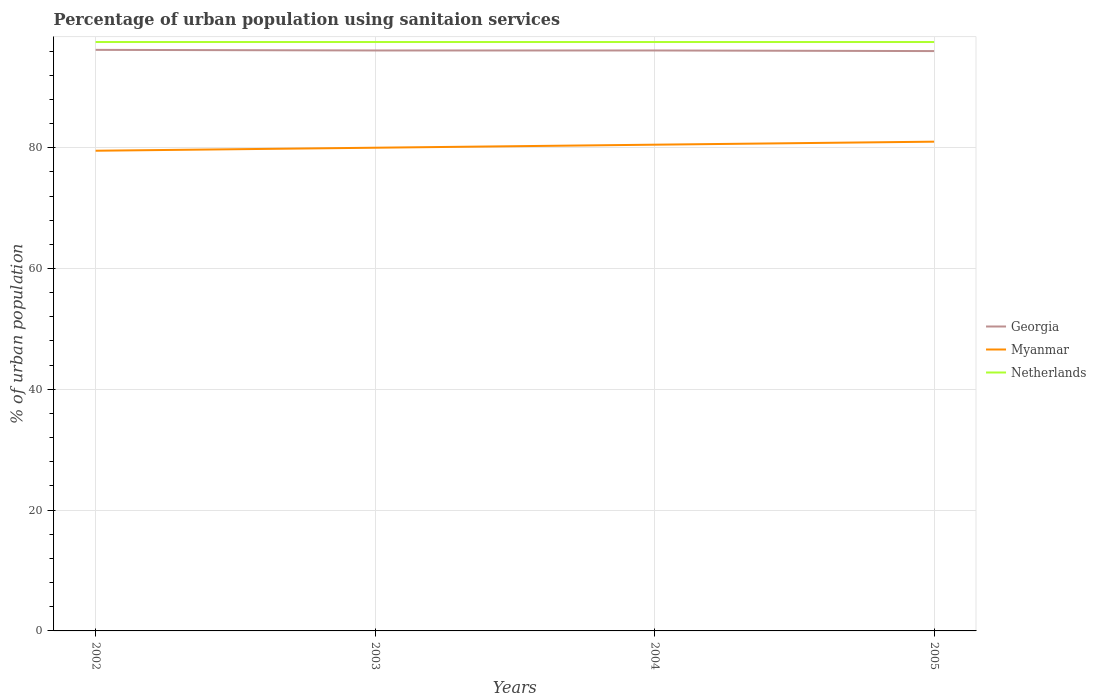Does the line corresponding to Netherlands intersect with the line corresponding to Myanmar?
Provide a succinct answer. No. Is the number of lines equal to the number of legend labels?
Your response must be concise. Yes. Across all years, what is the maximum percentage of urban population using sanitaion services in Myanmar?
Your answer should be very brief. 79.5. What is the difference between the highest and the second highest percentage of urban population using sanitaion services in Georgia?
Your answer should be very brief. 0.2. What is the difference between the highest and the lowest percentage of urban population using sanitaion services in Netherlands?
Keep it short and to the point. 0. What is the difference between two consecutive major ticks on the Y-axis?
Give a very brief answer. 20. Are the values on the major ticks of Y-axis written in scientific E-notation?
Provide a succinct answer. No. Does the graph contain any zero values?
Your answer should be compact. No. How many legend labels are there?
Make the answer very short. 3. What is the title of the graph?
Offer a terse response. Percentage of urban population using sanitaion services. What is the label or title of the Y-axis?
Ensure brevity in your answer.  % of urban population. What is the % of urban population of Georgia in 2002?
Provide a succinct answer. 96.2. What is the % of urban population in Myanmar in 2002?
Give a very brief answer. 79.5. What is the % of urban population of Netherlands in 2002?
Keep it short and to the point. 97.5. What is the % of urban population in Georgia in 2003?
Make the answer very short. 96.1. What is the % of urban population of Myanmar in 2003?
Offer a very short reply. 80. What is the % of urban population in Netherlands in 2003?
Provide a short and direct response. 97.5. What is the % of urban population in Georgia in 2004?
Provide a succinct answer. 96.1. What is the % of urban population in Myanmar in 2004?
Make the answer very short. 80.5. What is the % of urban population in Netherlands in 2004?
Offer a very short reply. 97.5. What is the % of urban population of Georgia in 2005?
Keep it short and to the point. 96. What is the % of urban population of Netherlands in 2005?
Your response must be concise. 97.5. Across all years, what is the maximum % of urban population of Georgia?
Offer a terse response. 96.2. Across all years, what is the maximum % of urban population in Netherlands?
Your answer should be compact. 97.5. Across all years, what is the minimum % of urban population in Georgia?
Make the answer very short. 96. Across all years, what is the minimum % of urban population in Myanmar?
Give a very brief answer. 79.5. Across all years, what is the minimum % of urban population in Netherlands?
Ensure brevity in your answer.  97.5. What is the total % of urban population in Georgia in the graph?
Provide a short and direct response. 384.4. What is the total % of urban population in Myanmar in the graph?
Your answer should be compact. 321. What is the total % of urban population of Netherlands in the graph?
Offer a terse response. 390. What is the difference between the % of urban population in Netherlands in 2002 and that in 2003?
Provide a short and direct response. 0. What is the difference between the % of urban population in Netherlands in 2002 and that in 2005?
Offer a very short reply. 0. What is the difference between the % of urban population of Netherlands in 2003 and that in 2005?
Your response must be concise. 0. What is the difference between the % of urban population in Netherlands in 2004 and that in 2005?
Provide a short and direct response. 0. What is the difference between the % of urban population of Georgia in 2002 and the % of urban population of Netherlands in 2003?
Your response must be concise. -1.3. What is the difference between the % of urban population of Georgia in 2002 and the % of urban population of Netherlands in 2004?
Offer a terse response. -1.3. What is the difference between the % of urban population of Myanmar in 2002 and the % of urban population of Netherlands in 2004?
Your answer should be compact. -18. What is the difference between the % of urban population in Georgia in 2002 and the % of urban population in Myanmar in 2005?
Offer a very short reply. 15.2. What is the difference between the % of urban population of Georgia in 2002 and the % of urban population of Netherlands in 2005?
Provide a succinct answer. -1.3. What is the difference between the % of urban population in Myanmar in 2002 and the % of urban population in Netherlands in 2005?
Your answer should be compact. -18. What is the difference between the % of urban population in Myanmar in 2003 and the % of urban population in Netherlands in 2004?
Keep it short and to the point. -17.5. What is the difference between the % of urban population in Georgia in 2003 and the % of urban population in Myanmar in 2005?
Your response must be concise. 15.1. What is the difference between the % of urban population of Myanmar in 2003 and the % of urban population of Netherlands in 2005?
Keep it short and to the point. -17.5. What is the difference between the % of urban population of Myanmar in 2004 and the % of urban population of Netherlands in 2005?
Ensure brevity in your answer.  -17. What is the average % of urban population in Georgia per year?
Ensure brevity in your answer.  96.1. What is the average % of urban population of Myanmar per year?
Ensure brevity in your answer.  80.25. What is the average % of urban population in Netherlands per year?
Provide a succinct answer. 97.5. In the year 2002, what is the difference between the % of urban population of Georgia and % of urban population of Myanmar?
Give a very brief answer. 16.7. In the year 2003, what is the difference between the % of urban population of Georgia and % of urban population of Myanmar?
Your answer should be very brief. 16.1. In the year 2003, what is the difference between the % of urban population in Myanmar and % of urban population in Netherlands?
Keep it short and to the point. -17.5. In the year 2004, what is the difference between the % of urban population in Georgia and % of urban population in Myanmar?
Provide a succinct answer. 15.6. In the year 2004, what is the difference between the % of urban population of Georgia and % of urban population of Netherlands?
Your answer should be very brief. -1.4. In the year 2004, what is the difference between the % of urban population of Myanmar and % of urban population of Netherlands?
Offer a very short reply. -17. In the year 2005, what is the difference between the % of urban population of Georgia and % of urban population of Myanmar?
Keep it short and to the point. 15. In the year 2005, what is the difference between the % of urban population of Georgia and % of urban population of Netherlands?
Keep it short and to the point. -1.5. In the year 2005, what is the difference between the % of urban population in Myanmar and % of urban population in Netherlands?
Offer a very short reply. -16.5. What is the ratio of the % of urban population in Georgia in 2002 to that in 2004?
Offer a very short reply. 1. What is the ratio of the % of urban population in Myanmar in 2002 to that in 2004?
Ensure brevity in your answer.  0.99. What is the ratio of the % of urban population in Georgia in 2002 to that in 2005?
Your response must be concise. 1. What is the ratio of the % of urban population in Myanmar in 2002 to that in 2005?
Your answer should be very brief. 0.98. What is the ratio of the % of urban population in Netherlands in 2002 to that in 2005?
Provide a succinct answer. 1. What is the ratio of the % of urban population of Myanmar in 2003 to that in 2004?
Offer a terse response. 0.99. What is the ratio of the % of urban population in Netherlands in 2003 to that in 2004?
Make the answer very short. 1. What is the ratio of the % of urban population in Myanmar in 2003 to that in 2005?
Ensure brevity in your answer.  0.99. What is the ratio of the % of urban population in Myanmar in 2004 to that in 2005?
Keep it short and to the point. 0.99. What is the ratio of the % of urban population in Netherlands in 2004 to that in 2005?
Offer a very short reply. 1. What is the difference between the highest and the second highest % of urban population in Georgia?
Ensure brevity in your answer.  0.1. What is the difference between the highest and the lowest % of urban population in Georgia?
Provide a short and direct response. 0.2. 